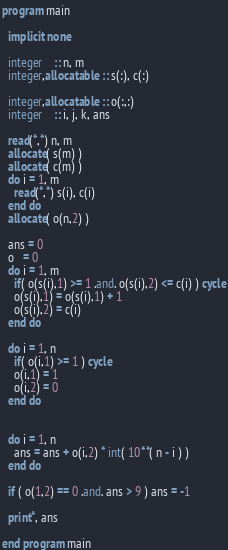Convert code to text. <code><loc_0><loc_0><loc_500><loc_500><_FORTRAN_>program main

  implicit none

  integer    :: n, m
  integer,allocatable :: s(:), c(:)

  integer,allocatable :: o(:,:)
  integer    :: i, j, k, ans

  read(*,*) n, m
  allocate( s(m) )
  allocate( c(m) )
  do i = 1, m
    read(*,*) s(i), c(i)
  end do
  allocate( o(n,2) )
  
  ans = 0 
  o   = 0
  do i = 1, m
    if( o(s(i),1) >= 1 .and. o(s(i),2) <= c(i) ) cycle
    o(s(i),1) = o(s(i),1) + 1
    o(s(i),2) = c(i)
  end do

  do i = 1, n
    if( o(i,1) >= 1 ) cycle
    o(i,1) = 1
    o(i,2) = 0
  end do

  
  do i = 1, n
    ans = ans + o(i,2) * int( 10**( n - i ) )
  end do

  if ( o(1,2) == 0 .and. ans > 9 ) ans = -1
  
  print*, ans
  
end program main
</code> 